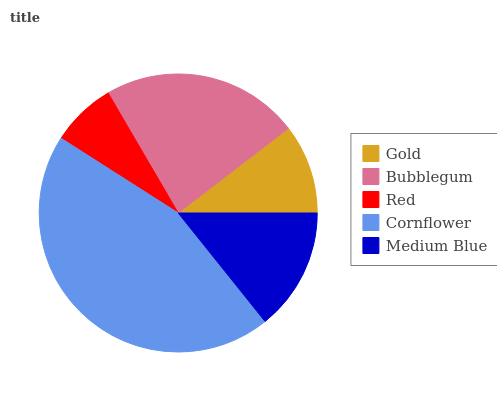Is Red the minimum?
Answer yes or no. Yes. Is Cornflower the maximum?
Answer yes or no. Yes. Is Bubblegum the minimum?
Answer yes or no. No. Is Bubblegum the maximum?
Answer yes or no. No. Is Bubblegum greater than Gold?
Answer yes or no. Yes. Is Gold less than Bubblegum?
Answer yes or no. Yes. Is Gold greater than Bubblegum?
Answer yes or no. No. Is Bubblegum less than Gold?
Answer yes or no. No. Is Medium Blue the high median?
Answer yes or no. Yes. Is Medium Blue the low median?
Answer yes or no. Yes. Is Bubblegum the high median?
Answer yes or no. No. Is Gold the low median?
Answer yes or no. No. 